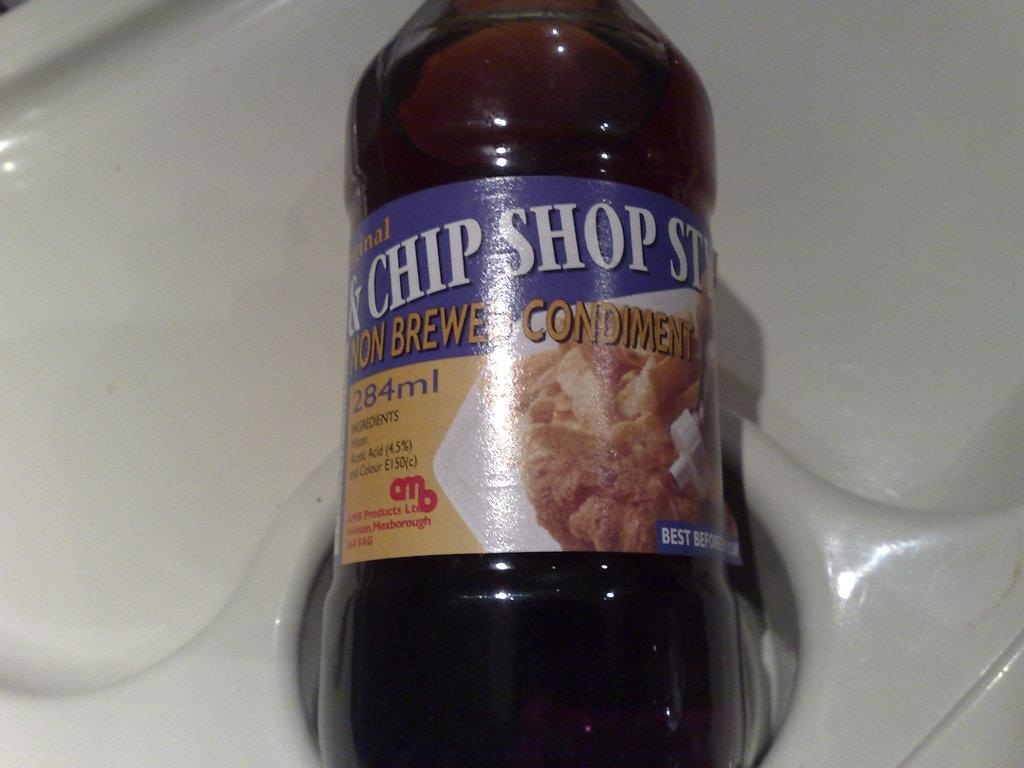<image>
Relay a brief, clear account of the picture shown. A jar contains 284 ml of a condiment item. 